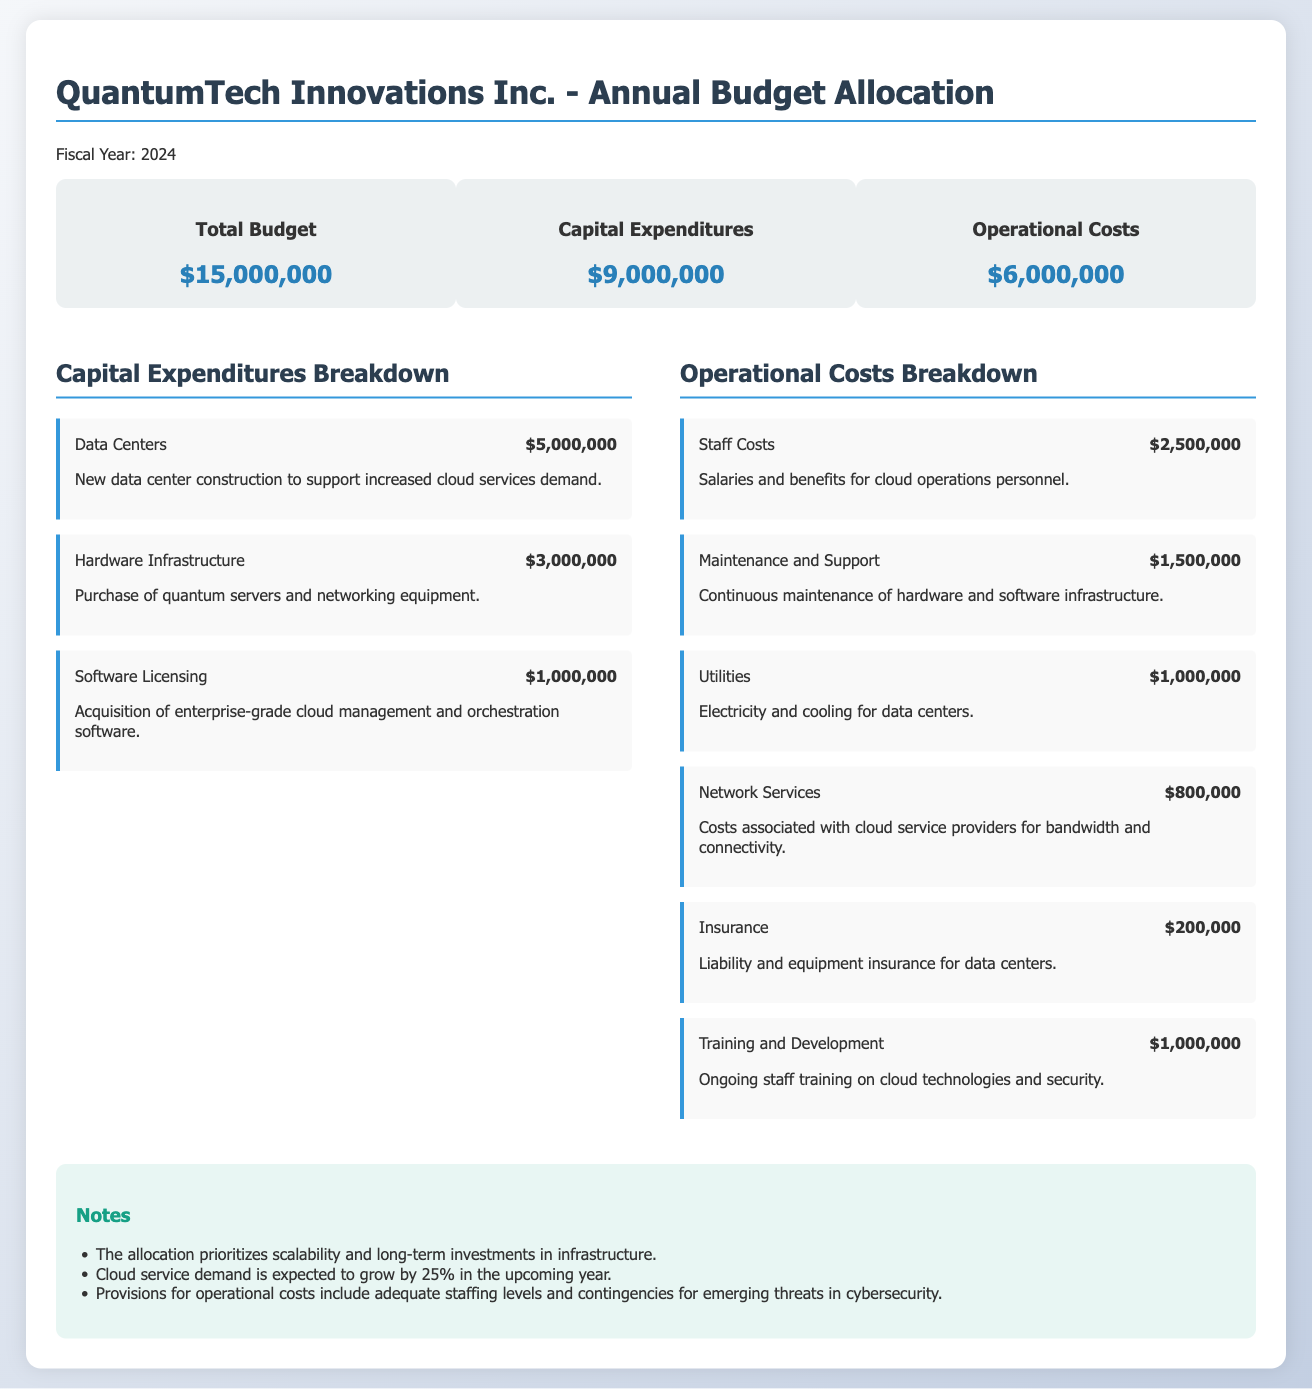what is the total budget? The total budget is explicitly mentioned in the document, which is $15,000,000.
Answer: $15,000,000 what are the capital expenditures? The capital expenditures are detailed in the budget summary, totaling $9,000,000.
Answer: $9,000,000 how much is allocated to data centers? The specific allocation for data center construction is provided within the capital expenditures breakdown.
Answer: $5,000,000 what is the largest operational cost component? The operational cost breakdown shows staff costs as the largest component.
Answer: $2,500,000 how much is spent on software licensing? The document lists the cost for software licensing under capital expenditures breakdown.
Answer: $1,000,000 what is the total operational cost? The total operational costs can be found in the budget summary, which is $6,000,000.
Answer: $6,000,000 what percentage growth in cloud service demand is expected? The notes section states an expected growth percentage for cloud service demand.
Answer: 25% how much is budgeted for training and development? The breakdown of operational costs includes a specific figure for training and development.
Answer: $1,000,000 what is the amount set aside for utilities? The operational cost breakdown provides an amount specifically for utilities expenses.
Answer: $1,000,000 